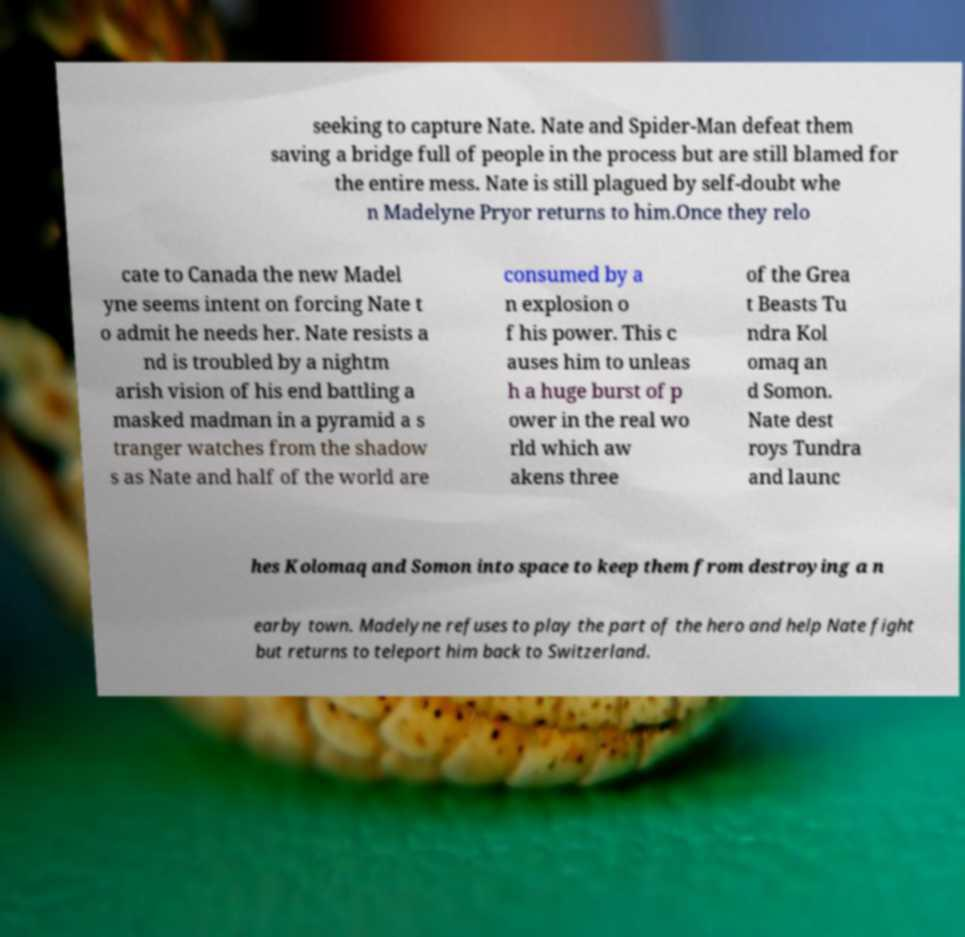Please read and relay the text visible in this image. What does it say? seeking to capture Nate. Nate and Spider-Man defeat them saving a bridge full of people in the process but are still blamed for the entire mess. Nate is still plagued by self-doubt whe n Madelyne Pryor returns to him.Once they relo cate to Canada the new Madel yne seems intent on forcing Nate t o admit he needs her. Nate resists a nd is troubled by a nightm arish vision of his end battling a masked madman in a pyramid a s tranger watches from the shadow s as Nate and half of the world are consumed by a n explosion o f his power. This c auses him to unleas h a huge burst of p ower in the real wo rld which aw akens three of the Grea t Beasts Tu ndra Kol omaq an d Somon. Nate dest roys Tundra and launc hes Kolomaq and Somon into space to keep them from destroying a n earby town. Madelyne refuses to play the part of the hero and help Nate fight but returns to teleport him back to Switzerland. 